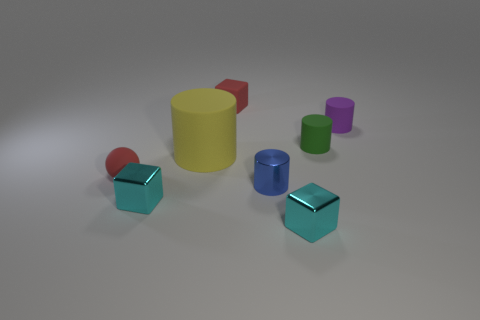Subtract all green matte cylinders. How many cylinders are left? 3 Add 1 tiny matte cylinders. How many objects exist? 9 Subtract all yellow cylinders. How many cylinders are left? 3 Subtract all balls. How many objects are left? 7 Subtract 1 cylinders. How many cylinders are left? 3 Subtract all red cylinders. Subtract all cyan cubes. How many cylinders are left? 4 Subtract all blue cylinders. How many cyan cubes are left? 2 Subtract all small red matte blocks. Subtract all yellow rubber things. How many objects are left? 6 Add 5 purple rubber objects. How many purple rubber objects are left? 6 Add 7 brown matte things. How many brown matte things exist? 7 